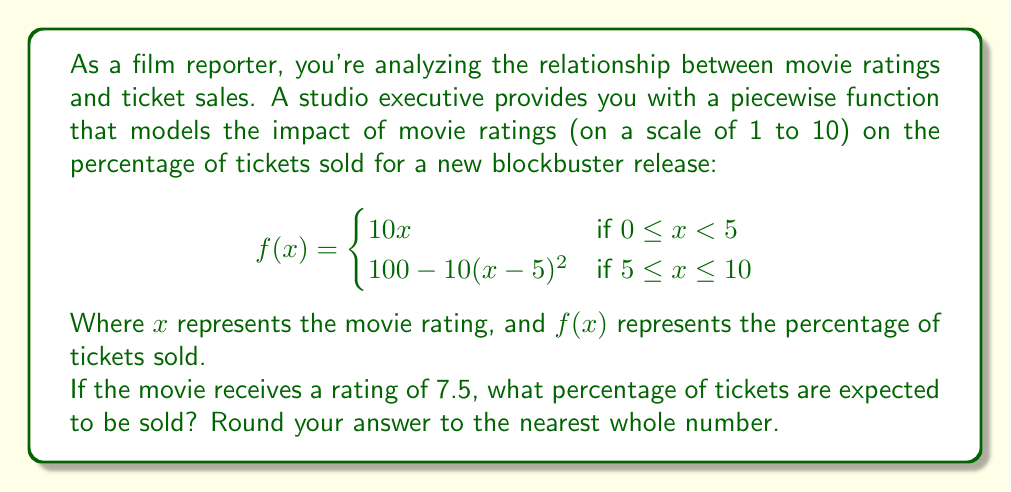Can you answer this question? To solve this problem, we need to use the given piecewise function and evaluate it at $x = 7.5$. Let's break it down step-by-step:

1. First, we need to determine which piece of the function to use. Since $7.5 \geq 5$, we'll use the second piece of the function:

   $f(x) = 100 - 10(x-5)^2$ for $5 \leq x \leq 10$

2. Now, let's substitute $x = 7.5$ into this equation:

   $f(7.5) = 100 - 10(7.5-5)^2$

3. Simplify the expression inside the parentheses:
   
   $f(7.5) = 100 - 10(2.5)^2$

4. Calculate the square:
   
   $f(7.5) = 100 - 10(6.25)$

5. Multiply:
   
   $f(7.5) = 100 - 62.5$

6. Subtract:
   
   $f(7.5) = 37.5$

7. Round to the nearest whole number:
   
   $f(7.5) \approx 38$

Therefore, if the movie receives a rating of 7.5, approximately 38% of tickets are expected to be sold.
Answer: 38% 